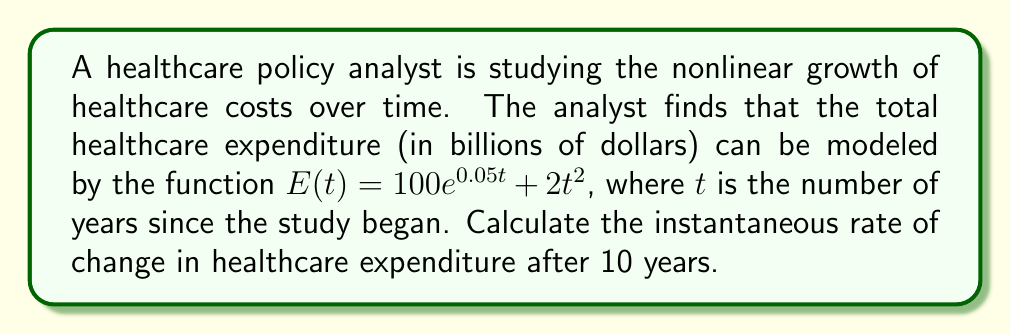What is the answer to this math problem? To find the instantaneous rate of change after 10 years, we need to calculate the derivative of the function $E(t)$ and evaluate it at $t=10$. Let's break this down step-by-step:

1) The given function is $E(t) = 100e^{0.05t} + 2t^2$

2) To find the derivative, we use the sum rule and apply the chain rule to the exponential term:

   $E'(t) = 100 \cdot 0.05e^{0.05t} + 2 \cdot 2t$
   
   $E'(t) = 5e^{0.05t} + 4t$

3) Now we need to evaluate this derivative at $t=10$:

   $E'(10) = 5e^{0.05(10)} + 4(10)$
   
   $E'(10) = 5e^{0.5} + 40$

4) Calculate $e^{0.5}$:
   
   $e^{0.5} \approx 1.6487$

5) Now we can complete the calculation:

   $E'(10) = 5(1.6487) + 40$
   
   $E'(10) = 8.2435 + 40 = 48.2435$

The instantaneous rate of change is measured in billions of dollars per year, so our final answer is approximately 48.2435 billion dollars per year.
Answer: $48.2435$ billion dollars per year 